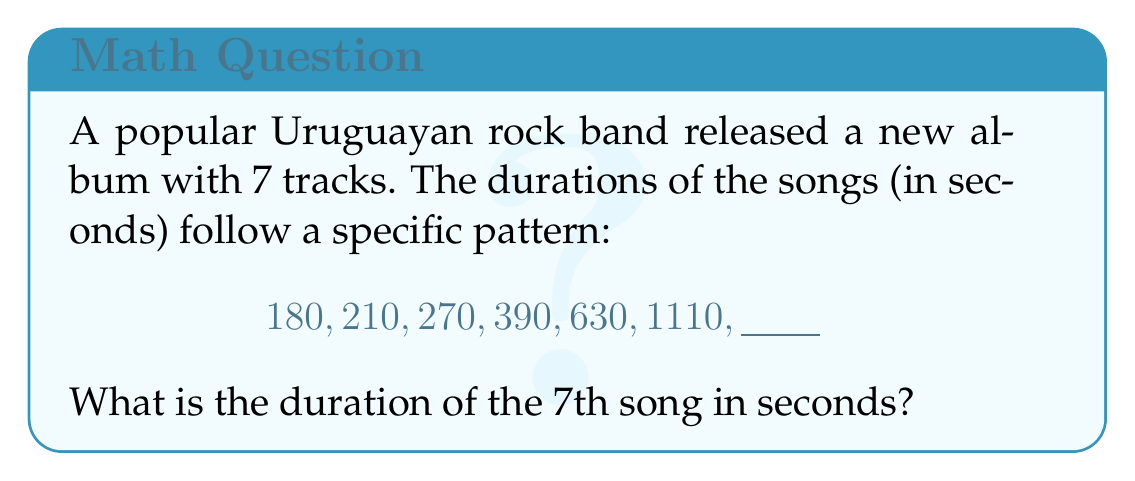What is the answer to this math problem? To solve this problem, let's follow these steps:

1) First, we need to identify the pattern in the given sequence. Let's look at the differences between consecutive terms:

   210 - 180 = 30
   270 - 210 = 60
   390 - 270 = 120
   630 - 390 = 240
   1110 - 630 = 480

2) We can see that these differences are also following a pattern:

   30, 60, 120, 240, 480

3) This is a geometric sequence with a common ratio of 2. Each term is twice the previous term.

4) So, we can expect the next difference to be:

   480 * 2 = 960

5) To find the 7th term, we add this difference to the 6th term:

   1110 + 960 = 2070

Therefore, the duration of the 7th song should be 2070 seconds.

We can verify this by writing out the full sequence:

$$180, 210, 270, 390, 630, 1110, 2070$$

This sequence can be represented by the formula:

$$a_n = 180 * (1 + \frac{1}{6})^{n-1}$$

Where $a_n$ is the nth term of the sequence.
Answer: 2070 